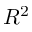<formula> <loc_0><loc_0><loc_500><loc_500>R ^ { 2 }</formula> 